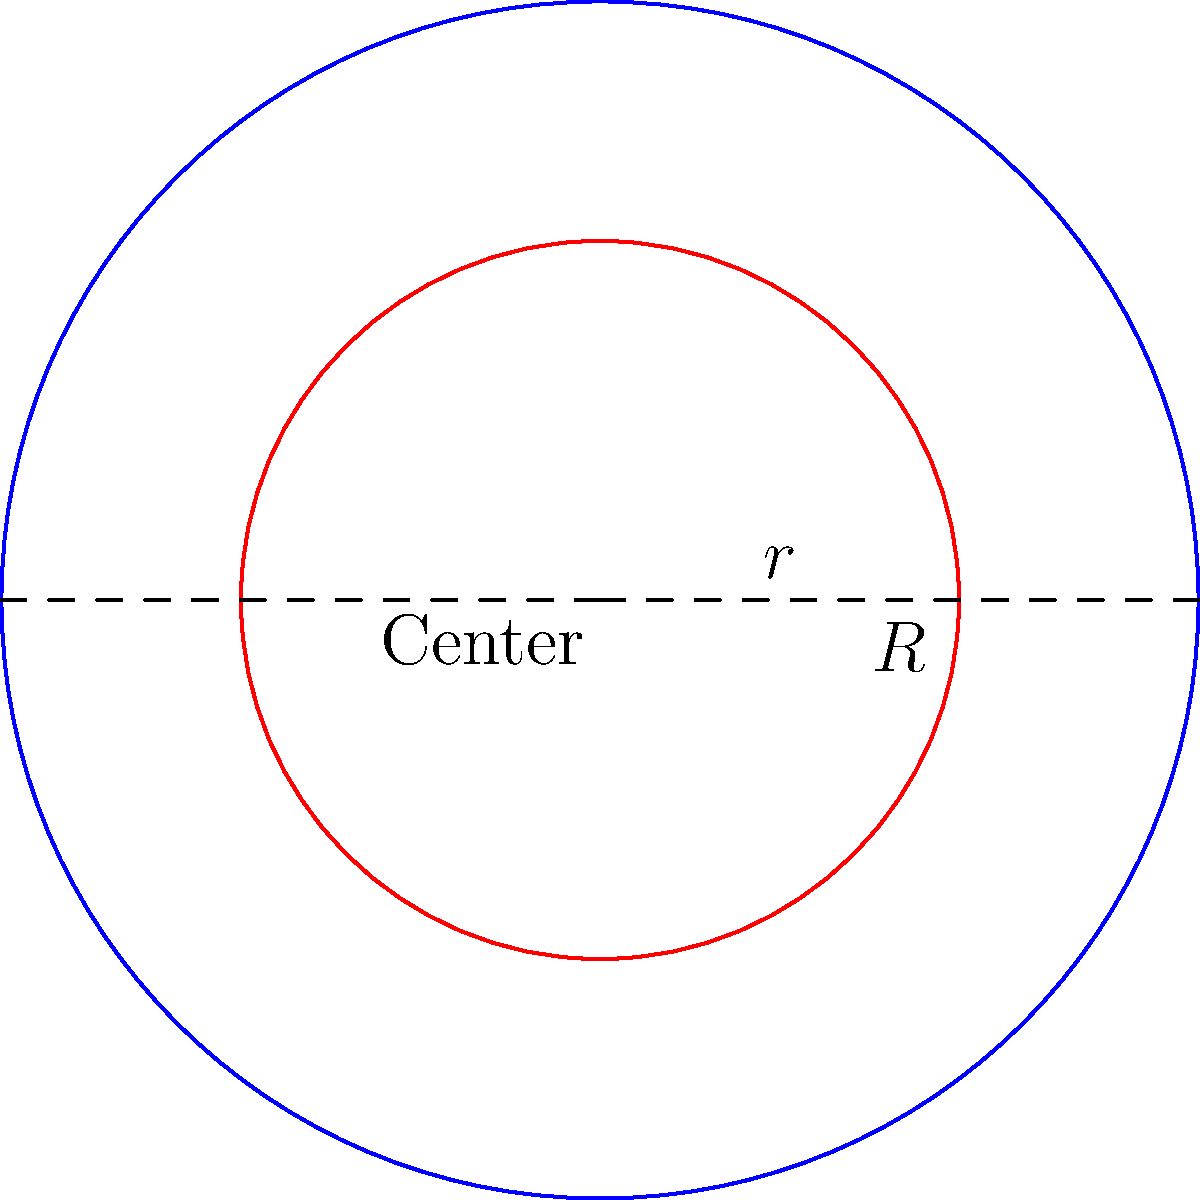You are designing a circular Mayan calendar carving with an outer radius of $R$ cm and an inner decorative circle with radius $r$ cm. The area between these circles will be filled with intricate designs. What value of $r$ will maximize the area available for these designs, given that $R = 5$ cm? To solve this optimization problem, we'll follow these steps:

1) The area available for designs is the difference between the areas of the outer and inner circles:
   $A = \pi R^2 - \pi r^2 = \pi(R^2 - r^2)$

2) We're given that $R = 5$ cm, so we can substitute this:
   $A = \pi(25 - r^2)$

3) To find the maximum, we need to differentiate $A$ with respect to $r$ and set it to zero:
   $\frac{dA}{dr} = -2\pi r$

4) Setting this equal to zero:
   $-2\pi r = 0$
   $r = 0$

5) The second derivative is $\frac{d^2A}{dr^2} = -2\pi$, which is always negative, confirming that $r = 0$ gives a maximum.

6) However, $r = 0$ isn't practical for our design. We need to find the maximum value of $r$ that still allows for a design area.

7) The area for designs is maximized when $r$ is as small as possible while still allowing for a practical inner circle.

8) In practice, the optimal $r$ would depend on the specific design requirements and tools used for pyrography. A common rule of thumb in design is the "Rule of Thirds," which would suggest $r = R/3 = 5/3 \approx 1.67$ cm.
Answer: $r \approx 1.67$ cm (based on the Rule of Thirds) 